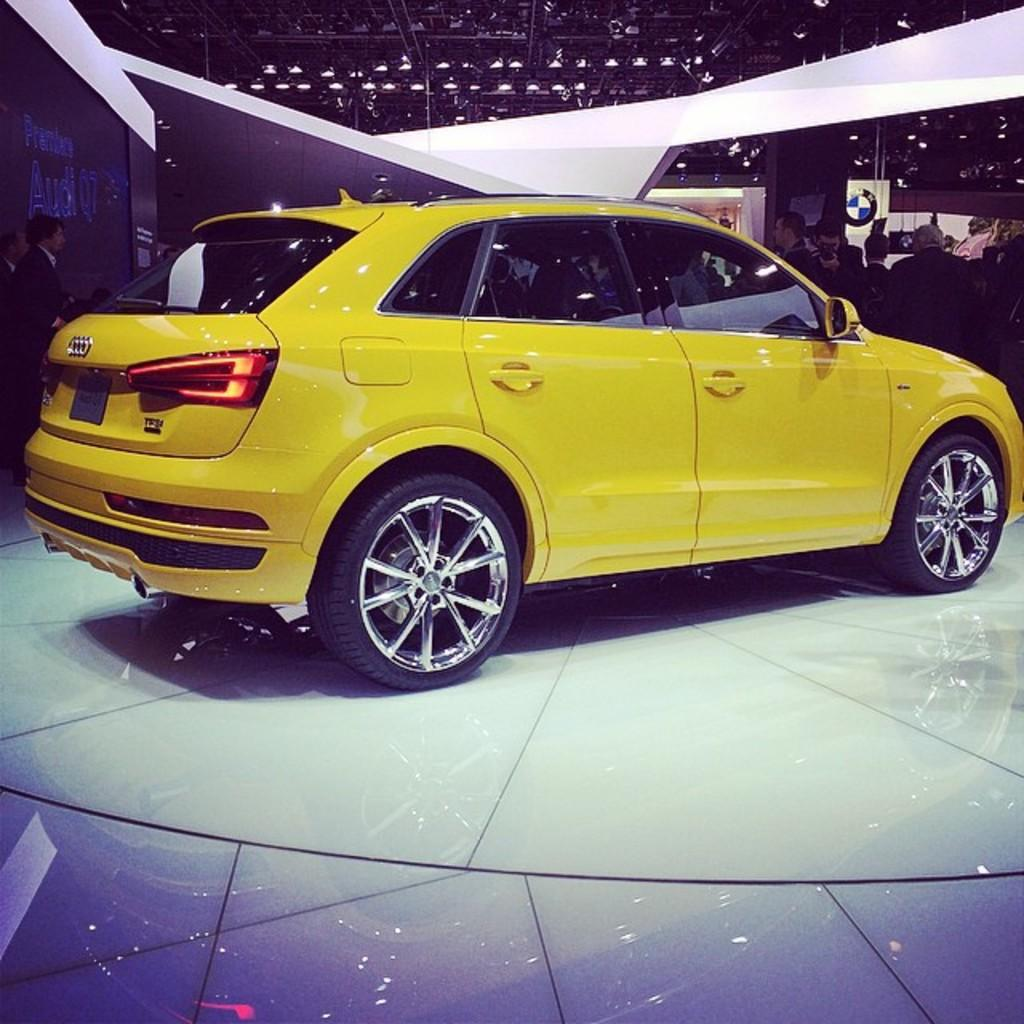What type of vehicle is in the foreground of the image? There is a yellow car in the foreground of the image. What can be seen in the background of the image? There are people, a poster, a roof, and a light in the background of the image. Can you describe the poster in the background? Unfortunately, the facts provided do not give any details about the poster. What might be the purpose of the light in the background? The light in the background could be for illumination or decoration. What type of bread is being used as a hobby in the image? There is no bread or hobby present in the image. What type of office furniture can be seen in the image? There is no office furniture present in the image. 